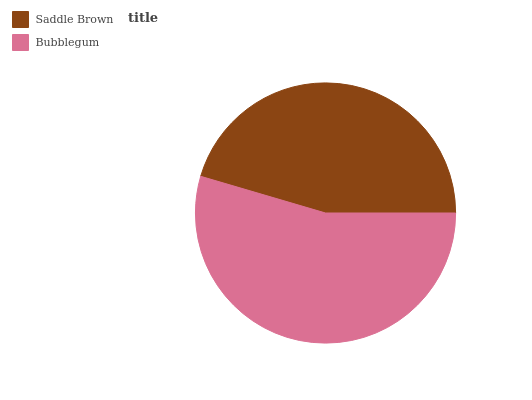Is Saddle Brown the minimum?
Answer yes or no. Yes. Is Bubblegum the maximum?
Answer yes or no. Yes. Is Bubblegum the minimum?
Answer yes or no. No. Is Bubblegum greater than Saddle Brown?
Answer yes or no. Yes. Is Saddle Brown less than Bubblegum?
Answer yes or no. Yes. Is Saddle Brown greater than Bubblegum?
Answer yes or no. No. Is Bubblegum less than Saddle Brown?
Answer yes or no. No. Is Bubblegum the high median?
Answer yes or no. Yes. Is Saddle Brown the low median?
Answer yes or no. Yes. Is Saddle Brown the high median?
Answer yes or no. No. Is Bubblegum the low median?
Answer yes or no. No. 